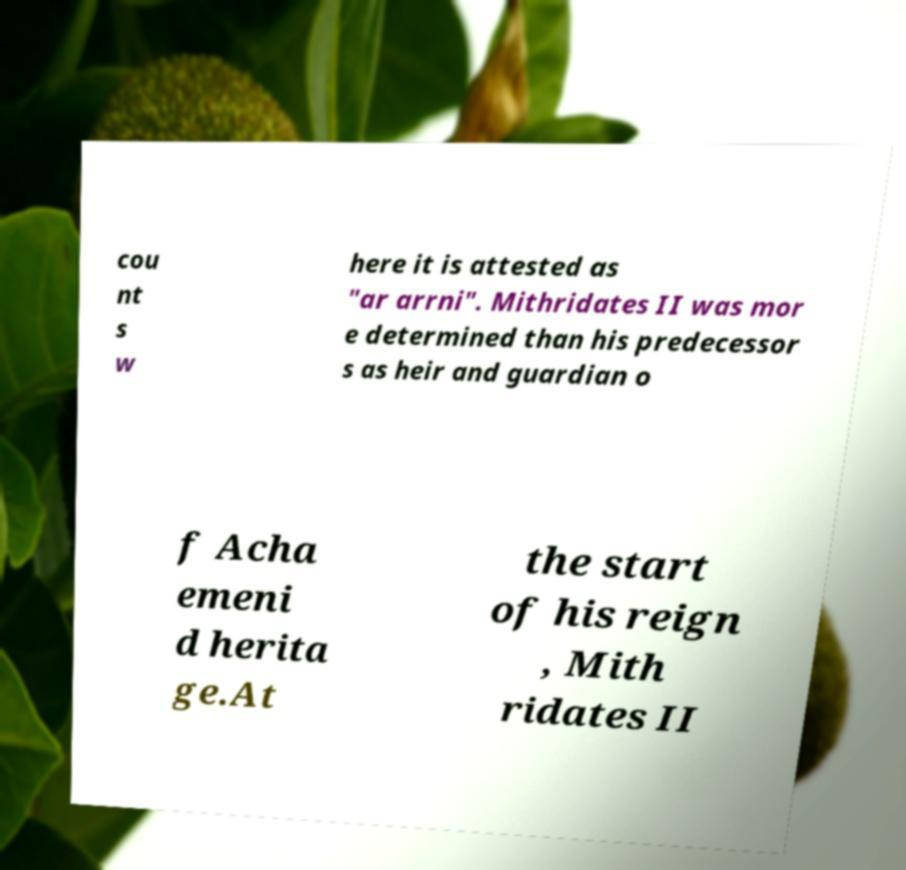Please identify and transcribe the text found in this image. cou nt s w here it is attested as "ar arrni". Mithridates II was mor e determined than his predecessor s as heir and guardian o f Acha emeni d herita ge.At the start of his reign , Mith ridates II 